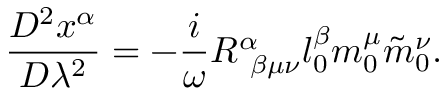<formula> <loc_0><loc_0><loc_500><loc_500>\frac { D ^ { 2 } x ^ { \alpha } } { D \lambda ^ { 2 } } = - \frac { i } { \omega } R _ { \beta \mu \nu } ^ { \alpha } l _ { 0 } ^ { \beta } m _ { 0 } ^ { \mu } \tilde { m } _ { 0 } ^ { \nu } .</formula> 